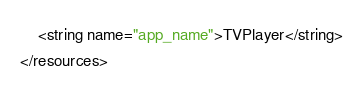<code> <loc_0><loc_0><loc_500><loc_500><_XML_>    <string name="app_name">TVPlayer</string>
</resources>
</code> 